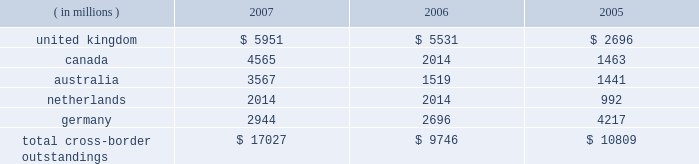Cross-border outstandings to countries in which we do business which amounted to at least 1% ( 1 % ) of our consolidated total assets were as follows as of december 31 : 2007 2006 2005 ( in millions ) .
The total cross-border outstandings presented in the table represented 12% ( 12 % ) , 9% ( 9 % ) and 11% ( 11 % ) of our consolidated total assets as of december 31 , 2007 , 2006 and 2005 , respectively .
There were no cross- border outstandings to countries which totaled between .75% ( .75 % ) and 1% ( 1 % ) of our consolidated total assets as of december 31 , 2007 .
Aggregate cross-border outstandings to countries which totaled between .75% ( .75 % ) and 1% ( 1 % ) of our consolidated total assets at december 31 , 2006 , amounted to $ 1.05 billion ( canada ) and at december 31 , 2005 , amounted to $ 1.86 billion ( belgium and japan ) .
Capital regulatory and economic capital management both use key metrics evaluated by management to ensure that our actual level of capital is commensurate with our risk profile , is in compliance with all regulatory requirements , and is sufficient to provide us with the financial flexibility to undertake future strategic business initiatives .
Regulatory capital our objective with respect to regulatory capital management is to maintain a strong capital base in order to provide financial flexibility for our business needs , including funding corporate growth and supporting customers 2019 cash management needs , and to provide protection against loss to depositors and creditors .
We strive to maintain an optimal level of capital , commensurate with our risk profile , on which an attractive return to shareholders will be realized over both the short and long term , while protecting our obligations to depositors and creditors and satisfying regulatory requirements .
Our capital management process focuses on our risk exposures , our capital position relative to our peers , regulatory capital requirements and the evaluations of the major independent credit rating agencies that assign ratings to our public debt .
The capital committee , working in conjunction with the asset and liability committee , referred to as 2018 2018alco , 2019 2019 oversees the management of regulatory capital , and is responsible for ensuring capital adequacy with respect to regulatory requirements , internal targets and the expectations of the major independent credit rating agencies .
The primary regulator of both state street and state street bank for regulatory capital purposes is the federal reserve board .
Both state street and state street bank are subject to the minimum capital requirements established by the federal reserve board and defined in the federal deposit insurance corporation improvement act of 1991 .
State street bank must meet the regulatory capital thresholds for 2018 2018well capitalized 2019 2019 in order for the parent company to maintain its status as a financial holding company. .
What was the percent change in cross-border outstandings in the uk between 2006 and 2007? 
Computations: ((5951 - 5531) / 5531)
Answer: 0.07594. Cross-border outstandings to countries in which we do business which amounted to at least 1% ( 1 % ) of our consolidated total assets were as follows as of december 31 : 2007 2006 2005 ( in millions ) .
The total cross-border outstandings presented in the table represented 12% ( 12 % ) , 9% ( 9 % ) and 11% ( 11 % ) of our consolidated total assets as of december 31 , 2007 , 2006 and 2005 , respectively .
There were no cross- border outstandings to countries which totaled between .75% ( .75 % ) and 1% ( 1 % ) of our consolidated total assets as of december 31 , 2007 .
Aggregate cross-border outstandings to countries which totaled between .75% ( .75 % ) and 1% ( 1 % ) of our consolidated total assets at december 31 , 2006 , amounted to $ 1.05 billion ( canada ) and at december 31 , 2005 , amounted to $ 1.86 billion ( belgium and japan ) .
Capital regulatory and economic capital management both use key metrics evaluated by management to ensure that our actual level of capital is commensurate with our risk profile , is in compliance with all regulatory requirements , and is sufficient to provide us with the financial flexibility to undertake future strategic business initiatives .
Regulatory capital our objective with respect to regulatory capital management is to maintain a strong capital base in order to provide financial flexibility for our business needs , including funding corporate growth and supporting customers 2019 cash management needs , and to provide protection against loss to depositors and creditors .
We strive to maintain an optimal level of capital , commensurate with our risk profile , on which an attractive return to shareholders will be realized over both the short and long term , while protecting our obligations to depositors and creditors and satisfying regulatory requirements .
Our capital management process focuses on our risk exposures , our capital position relative to our peers , regulatory capital requirements and the evaluations of the major independent credit rating agencies that assign ratings to our public debt .
The capital committee , working in conjunction with the asset and liability committee , referred to as 2018 2018alco , 2019 2019 oversees the management of regulatory capital , and is responsible for ensuring capital adequacy with respect to regulatory requirements , internal targets and the expectations of the major independent credit rating agencies .
The primary regulator of both state street and state street bank for regulatory capital purposes is the federal reserve board .
Both state street and state street bank are subject to the minimum capital requirements established by the federal reserve board and defined in the federal deposit insurance corporation improvement act of 1991 .
State street bank must meet the regulatory capital thresholds for 2018 2018well capitalized 2019 2019 in order for the parent company to maintain its status as a financial holding company. .
What was the value of the company's consolidated total assets , in millions of dollars , as of december 31 , 2007? 
Computations: (17027 / 12%)
Answer: 141891.66667. 